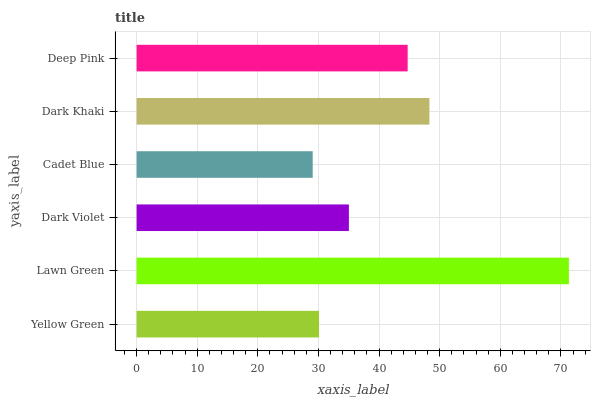Is Cadet Blue the minimum?
Answer yes or no. Yes. Is Lawn Green the maximum?
Answer yes or no. Yes. Is Dark Violet the minimum?
Answer yes or no. No. Is Dark Violet the maximum?
Answer yes or no. No. Is Lawn Green greater than Dark Violet?
Answer yes or no. Yes. Is Dark Violet less than Lawn Green?
Answer yes or no. Yes. Is Dark Violet greater than Lawn Green?
Answer yes or no. No. Is Lawn Green less than Dark Violet?
Answer yes or no. No. Is Deep Pink the high median?
Answer yes or no. Yes. Is Dark Violet the low median?
Answer yes or no. Yes. Is Dark Khaki the high median?
Answer yes or no. No. Is Dark Khaki the low median?
Answer yes or no. No. 